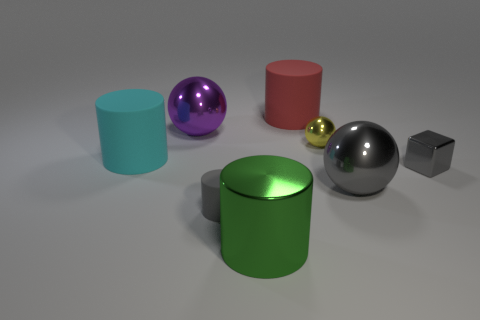The objects appear to have different finishes. Which ones are shiny? Indeed, there is a variety in finishes. The purple sphere, yellow sphere, large grey sphere, and the small grey cube exhibit shiny, reflective surfaces, while the cyan and green cylinders and the red cylinder have a matte finish. 